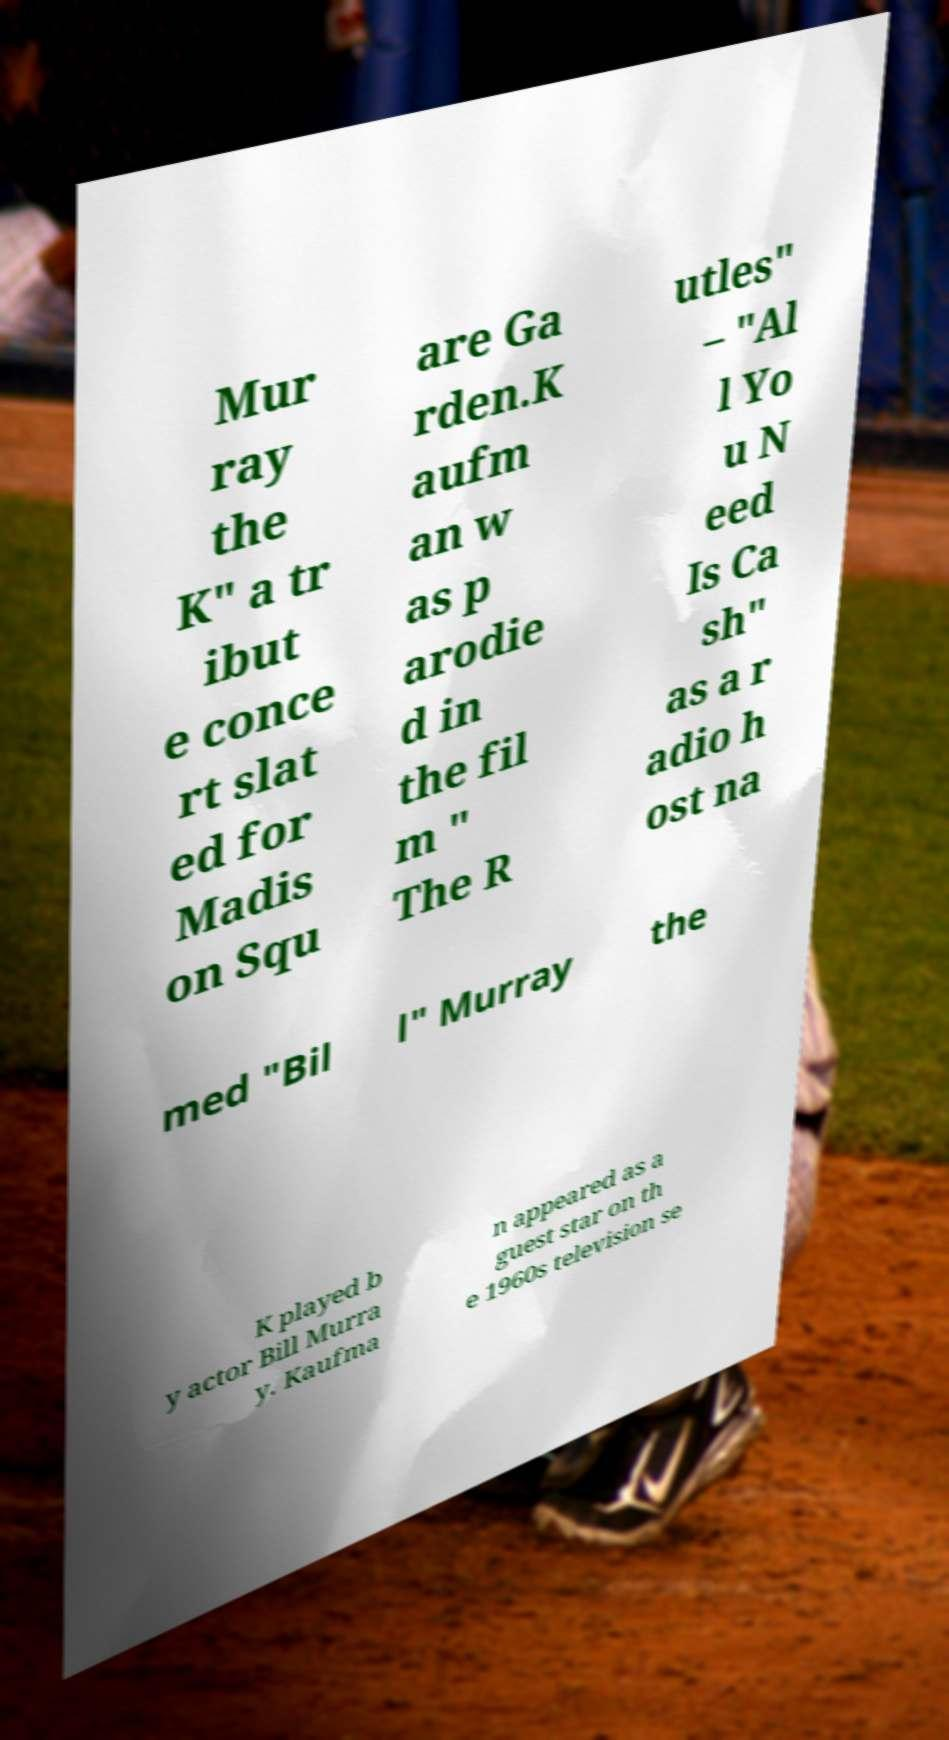Could you extract and type out the text from this image? Mur ray the K" a tr ibut e conce rt slat ed for Madis on Squ are Ga rden.K aufm an w as p arodie d in the fil m " The R utles" – "Al l Yo u N eed Is Ca sh" as a r adio h ost na med "Bil l" Murray the K played b y actor Bill Murra y. Kaufma n appeared as a guest star on th e 1960s television se 